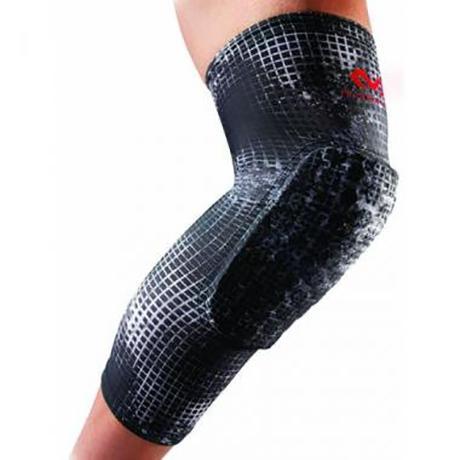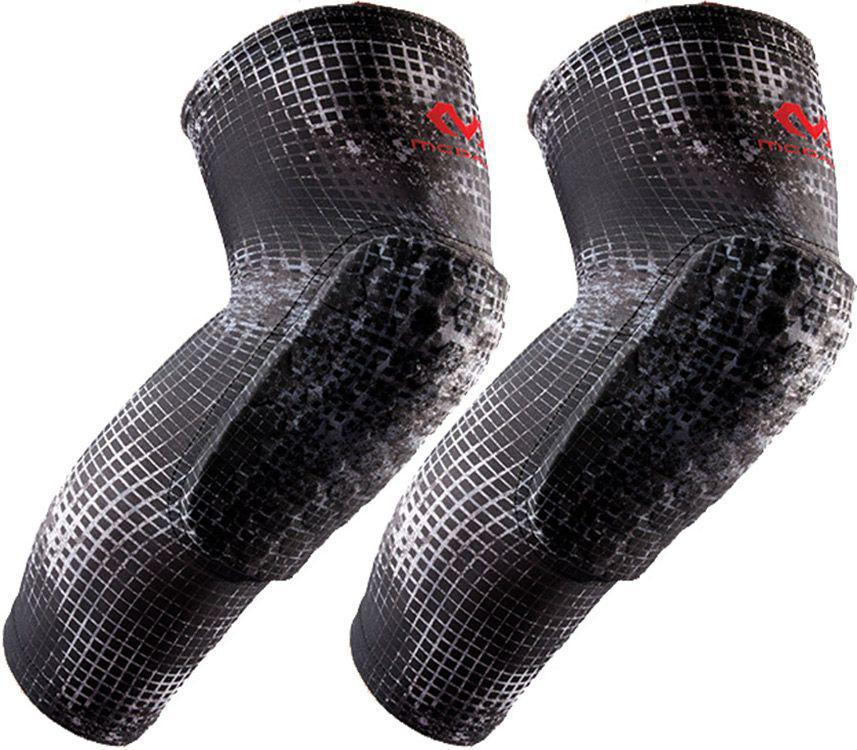The first image is the image on the left, the second image is the image on the right. Analyze the images presented: Is the assertion "There is a white knee pad next to a red knee pad" valid? Answer yes or no. No. The first image is the image on the left, the second image is the image on the right. Evaluate the accuracy of this statement regarding the images: "One of the images shows exactly one knee pad.". Is it true? Answer yes or no. Yes. 